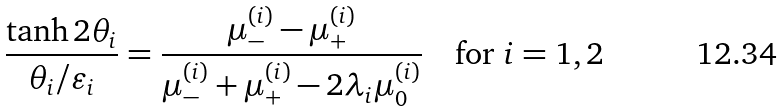Convert formula to latex. <formula><loc_0><loc_0><loc_500><loc_500>\frac { \tanh 2 \theta _ { i } } { \theta _ { i } / \varepsilon _ { i } } = \frac { \mu _ { - } ^ { ( i ) } - \mu _ { + } ^ { ( i ) } } { \mu _ { - } ^ { ( i ) } + \mu _ { + } ^ { ( i ) } - 2 \lambda _ { i } \mu _ { 0 } ^ { ( i ) } } \quad \text {for } i = 1 , 2</formula> 